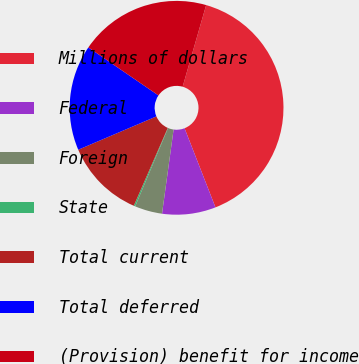Convert chart. <chart><loc_0><loc_0><loc_500><loc_500><pie_chart><fcel>Millions of dollars<fcel>Federal<fcel>Foreign<fcel>State<fcel>Total current<fcel>Total deferred<fcel>(Provision) benefit for income<nl><fcel>39.61%<fcel>8.1%<fcel>4.16%<fcel>0.22%<fcel>12.03%<fcel>15.97%<fcel>19.91%<nl></chart> 